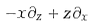Convert formula to latex. <formula><loc_0><loc_0><loc_500><loc_500>- x \partial _ { z } + z \partial _ { x }</formula> 